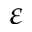Convert formula to latex. <formula><loc_0><loc_0><loc_500><loc_500>\varepsilon</formula> 